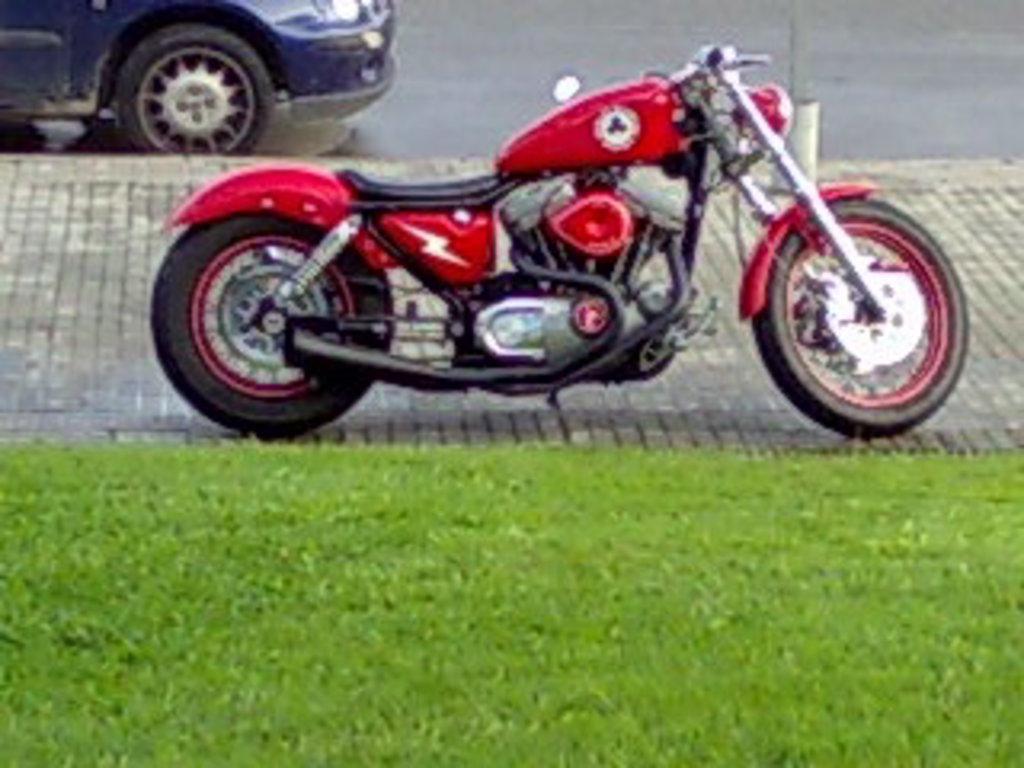In one or two sentences, can you explain what this image depicts? In this image we can see motor vehicles on the floor and road. In the foreground there is grass. 